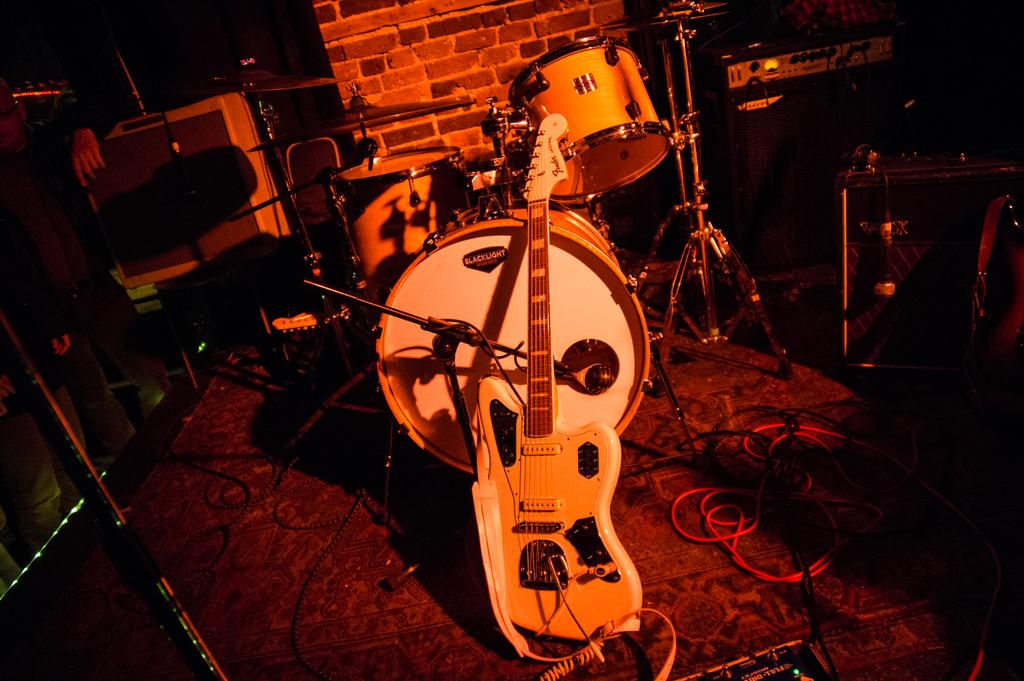What musical instrument can be seen in the image? There is a guitar in the image. What other musical instruments are present in the image? There are drums in the image. What is used for amplifying vocals in the image? There is a mic stand in the image. What connects the instruments and equipment in the image? There are wires in the image. What is the background of the image? There is a wall in the image. How would you describe the lighting in the image? The image appears to be dark. How many pies are being served on the table in the image? There are no pies present in the image; it features musical instruments and equipment. What type of pen is being used to write on the wall in the image? There is no pen or writing on the wall in the image. 